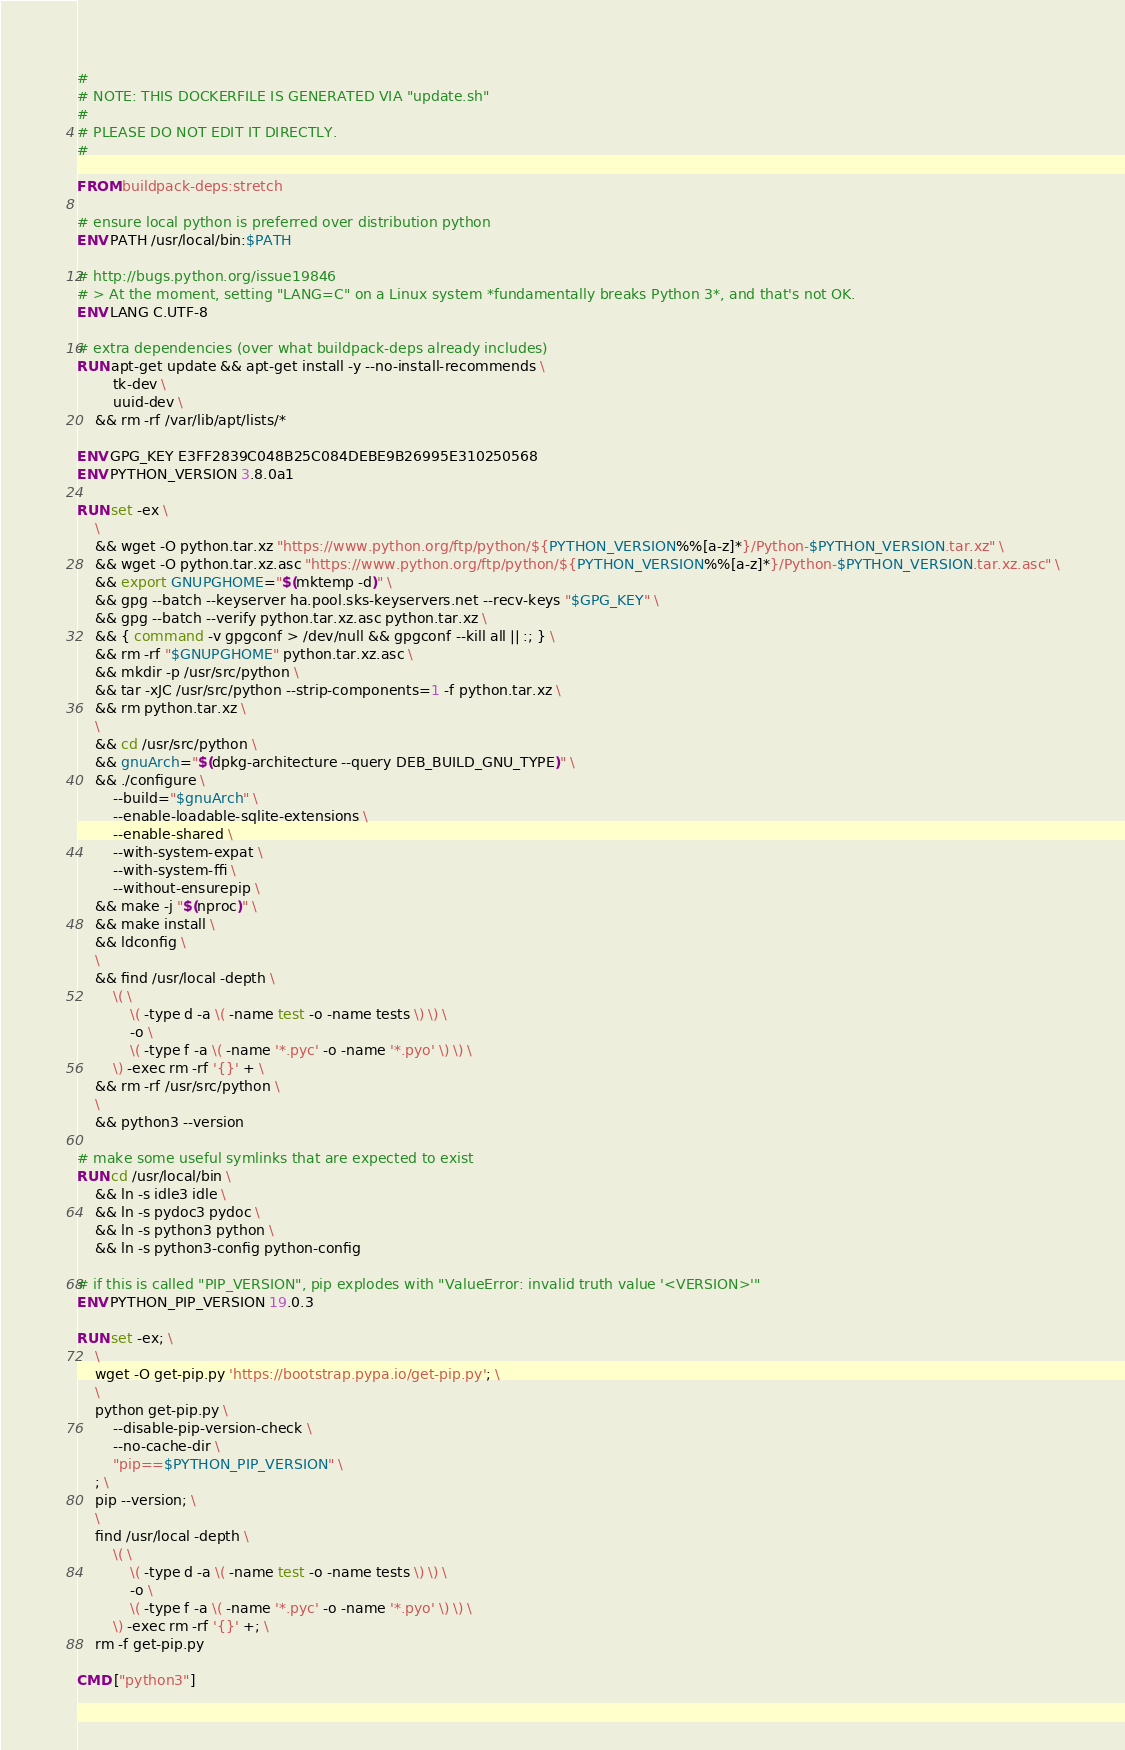<code> <loc_0><loc_0><loc_500><loc_500><_Dockerfile_>#
# NOTE: THIS DOCKERFILE IS GENERATED VIA "update.sh"
#
# PLEASE DO NOT EDIT IT DIRECTLY.
#

FROM buildpack-deps:stretch

# ensure local python is preferred over distribution python
ENV PATH /usr/local/bin:$PATH

# http://bugs.python.org/issue19846
# > At the moment, setting "LANG=C" on a Linux system *fundamentally breaks Python 3*, and that's not OK.
ENV LANG C.UTF-8

# extra dependencies (over what buildpack-deps already includes)
RUN apt-get update && apt-get install -y --no-install-recommends \
		tk-dev \
		uuid-dev \
	&& rm -rf /var/lib/apt/lists/*

ENV GPG_KEY E3FF2839C048B25C084DEBE9B26995E310250568
ENV PYTHON_VERSION 3.8.0a1

RUN set -ex \
	\
	&& wget -O python.tar.xz "https://www.python.org/ftp/python/${PYTHON_VERSION%%[a-z]*}/Python-$PYTHON_VERSION.tar.xz" \
	&& wget -O python.tar.xz.asc "https://www.python.org/ftp/python/${PYTHON_VERSION%%[a-z]*}/Python-$PYTHON_VERSION.tar.xz.asc" \
	&& export GNUPGHOME="$(mktemp -d)" \
	&& gpg --batch --keyserver ha.pool.sks-keyservers.net --recv-keys "$GPG_KEY" \
	&& gpg --batch --verify python.tar.xz.asc python.tar.xz \
	&& { command -v gpgconf > /dev/null && gpgconf --kill all || :; } \
	&& rm -rf "$GNUPGHOME" python.tar.xz.asc \
	&& mkdir -p /usr/src/python \
	&& tar -xJC /usr/src/python --strip-components=1 -f python.tar.xz \
	&& rm python.tar.xz \
	\
	&& cd /usr/src/python \
	&& gnuArch="$(dpkg-architecture --query DEB_BUILD_GNU_TYPE)" \
	&& ./configure \
		--build="$gnuArch" \
		--enable-loadable-sqlite-extensions \
		--enable-shared \
		--with-system-expat \
		--with-system-ffi \
		--without-ensurepip \
	&& make -j "$(nproc)" \
	&& make install \
	&& ldconfig \
	\
	&& find /usr/local -depth \
		\( \
			\( -type d -a \( -name test -o -name tests \) \) \
			-o \
			\( -type f -a \( -name '*.pyc' -o -name '*.pyo' \) \) \
		\) -exec rm -rf '{}' + \
	&& rm -rf /usr/src/python \
	\
	&& python3 --version

# make some useful symlinks that are expected to exist
RUN cd /usr/local/bin \
	&& ln -s idle3 idle \
	&& ln -s pydoc3 pydoc \
	&& ln -s python3 python \
	&& ln -s python3-config python-config

# if this is called "PIP_VERSION", pip explodes with "ValueError: invalid truth value '<VERSION>'"
ENV PYTHON_PIP_VERSION 19.0.3

RUN set -ex; \
	\
	wget -O get-pip.py 'https://bootstrap.pypa.io/get-pip.py'; \
	\
	python get-pip.py \
		--disable-pip-version-check \
		--no-cache-dir \
		"pip==$PYTHON_PIP_VERSION" \
	; \
	pip --version; \
	\
	find /usr/local -depth \
		\( \
			\( -type d -a \( -name test -o -name tests \) \) \
			-o \
			\( -type f -a \( -name '*.pyc' -o -name '*.pyo' \) \) \
		\) -exec rm -rf '{}' +; \
	rm -f get-pip.py

CMD ["python3"]
</code> 